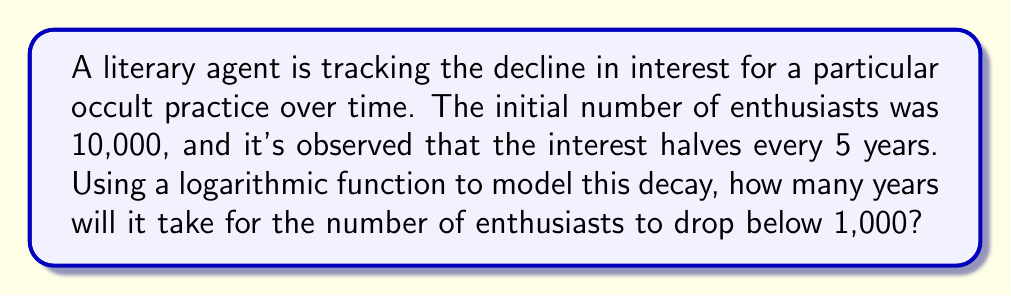Solve this math problem. Let's approach this step-by-step:

1) The general form of an exponential decay function is:
   $$ N(t) = N_0 \cdot b^t $$
   where $N(t)$ is the number at time $t$, $N_0$ is the initial number, and $b$ is the base.

2) We know that the interest halves every 5 years, so:
   $$ \frac{1}{2} = b^5 $$

3) Solving for $b$:
   $$ b = (\frac{1}{2})^{\frac{1}{5}} \approx 0.8706 $$

4) Now our function is:
   $$ N(t) = 10000 \cdot (0.8706)^t $$

5) We want to find $t$ when $N(t) < 1000$:
   $$ 1000 = 10000 \cdot (0.8706)^t $$

6) Dividing both sides by 10000:
   $$ 0.1 = (0.8706)^t $$

7) Taking the natural log of both sides:
   $$ \ln(0.1) = t \cdot \ln(0.8706) $$

8) Solving for $t$:
   $$ t = \frac{\ln(0.1)}{\ln(0.8706)} \approx 16.96 $$

Therefore, it will take approximately 16.96 years for the number of enthusiasts to drop below 1,000.
Answer: 16.96 years 